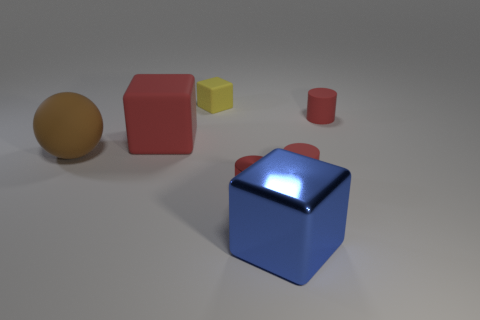Subtract all large red blocks. How many blocks are left? 2 Add 1 brown objects. How many objects exist? 8 Subtract all balls. How many objects are left? 6 Subtract all blue cubes. How many cubes are left? 2 Subtract all cyan cylinders. Subtract all cyan blocks. How many cylinders are left? 3 Subtract all yellow matte cubes. Subtract all small cylinders. How many objects are left? 3 Add 7 large spheres. How many large spheres are left? 8 Add 3 brown spheres. How many brown spheres exist? 4 Subtract 0 gray balls. How many objects are left? 7 Subtract 1 spheres. How many spheres are left? 0 